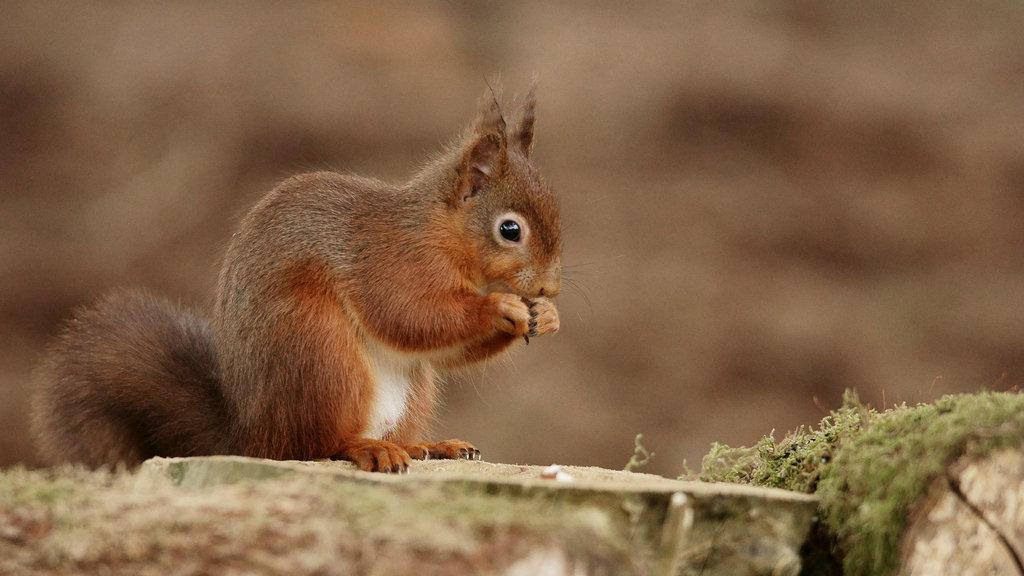What animal can be seen on the ground on the left side of the image? There is a squirrel on the ground on the left side of the image. What type of vegetation is visible on the right side of the image? There is grass on the right side of the image. Can you describe the background of the image? The background of the image is blurred. What type of pancake is being flipped in the air in the image? There is no pancake present in the image, and no one is flipping anything in the air. 